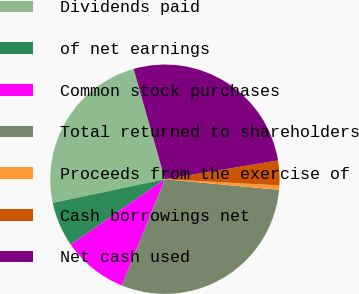<chart> <loc_0><loc_0><loc_500><loc_500><pie_chart><fcel>Dividends paid<fcel>of net earnings<fcel>Common stock purchases<fcel>Total returned to shareholders<fcel>Proceeds from the exercise of<fcel>Cash borrowings net<fcel>Net cash used<nl><fcel>23.92%<fcel>6.35%<fcel>9.21%<fcel>29.65%<fcel>0.62%<fcel>3.48%<fcel>26.78%<nl></chart> 